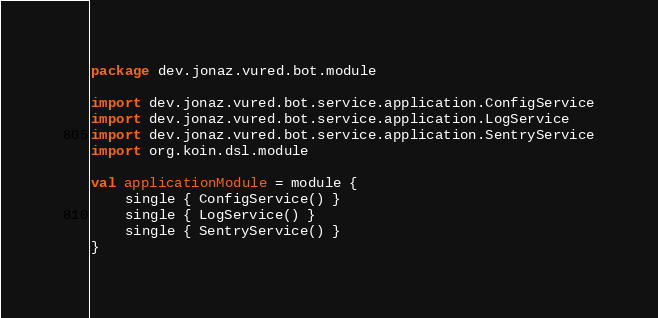Convert code to text. <code><loc_0><loc_0><loc_500><loc_500><_Kotlin_>package dev.jonaz.vured.bot.module

import dev.jonaz.vured.bot.service.application.ConfigService
import dev.jonaz.vured.bot.service.application.LogService
import dev.jonaz.vured.bot.service.application.SentryService
import org.koin.dsl.module

val applicationModule = module {
    single { ConfigService() }
    single { LogService() }
    single { SentryService() }
}
</code> 